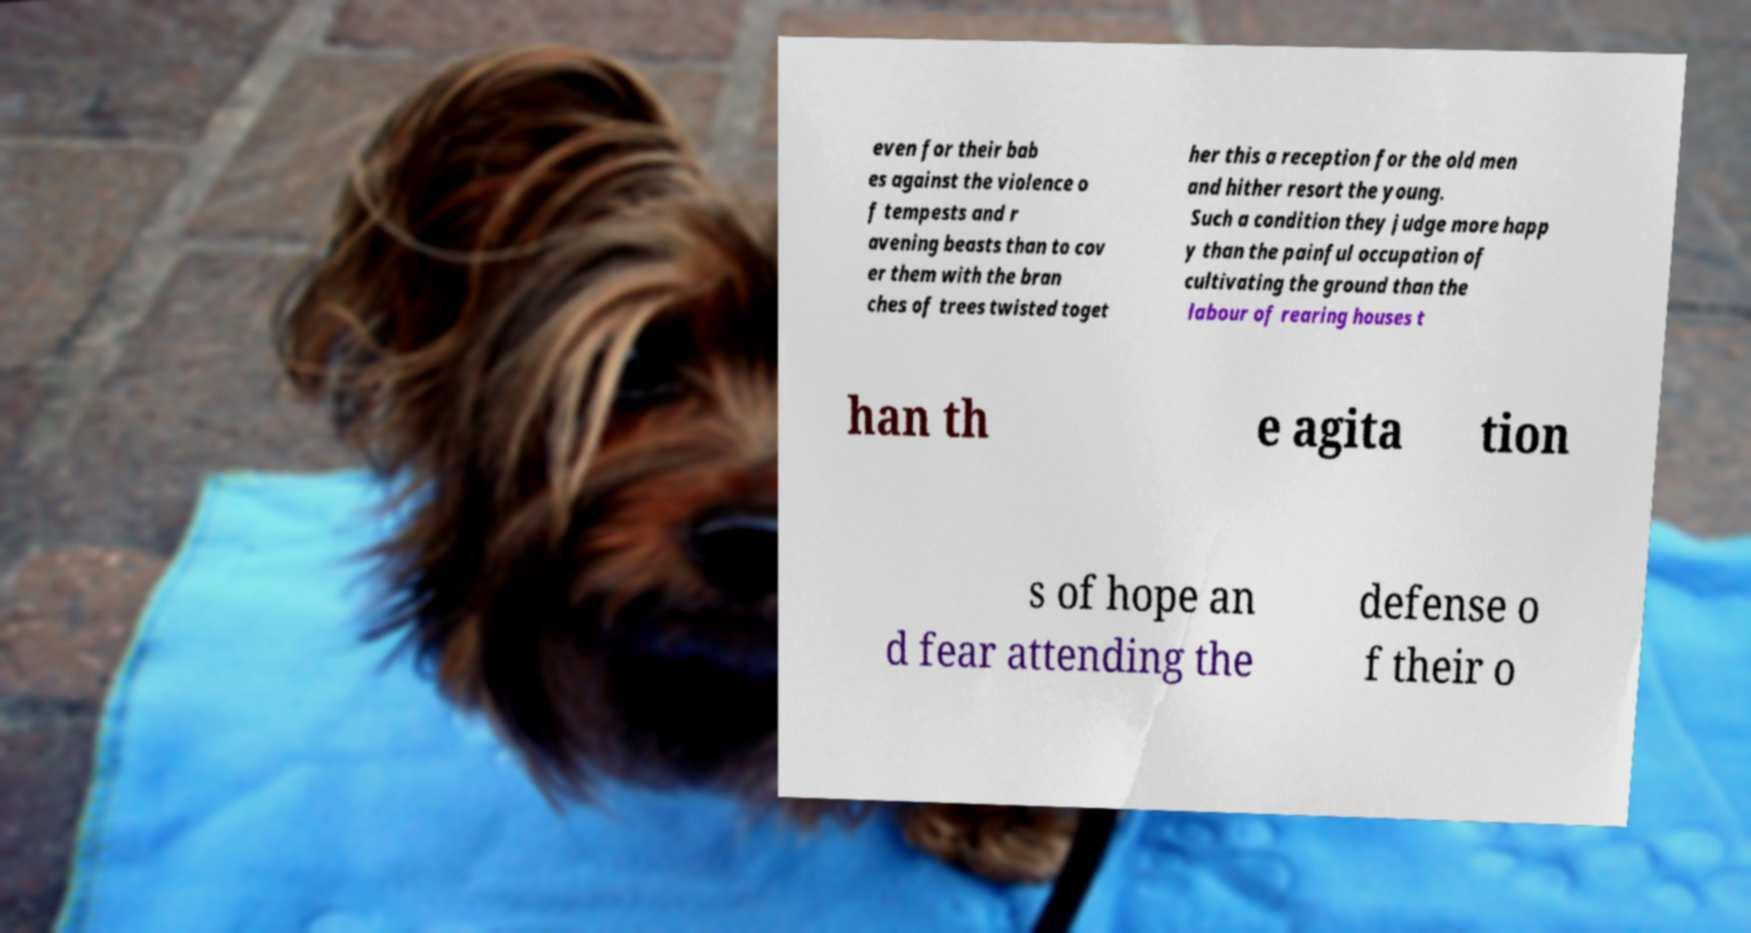Could you assist in decoding the text presented in this image and type it out clearly? even for their bab es against the violence o f tempests and r avening beasts than to cov er them with the bran ches of trees twisted toget her this a reception for the old men and hither resort the young. Such a condition they judge more happ y than the painful occupation of cultivating the ground than the labour of rearing houses t han th e agita tion s of hope an d fear attending the defense o f their o 